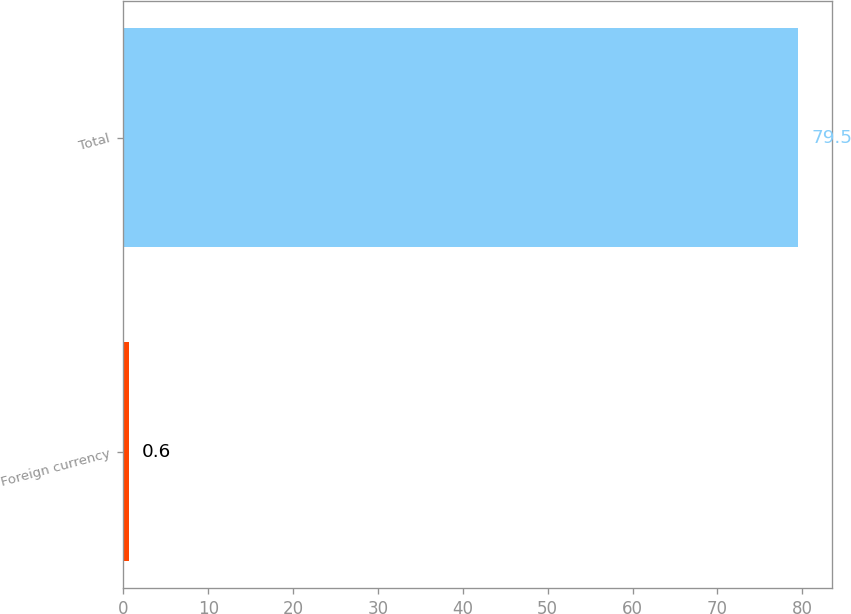Convert chart. <chart><loc_0><loc_0><loc_500><loc_500><bar_chart><fcel>Foreign currency<fcel>Total<nl><fcel>0.6<fcel>79.5<nl></chart> 